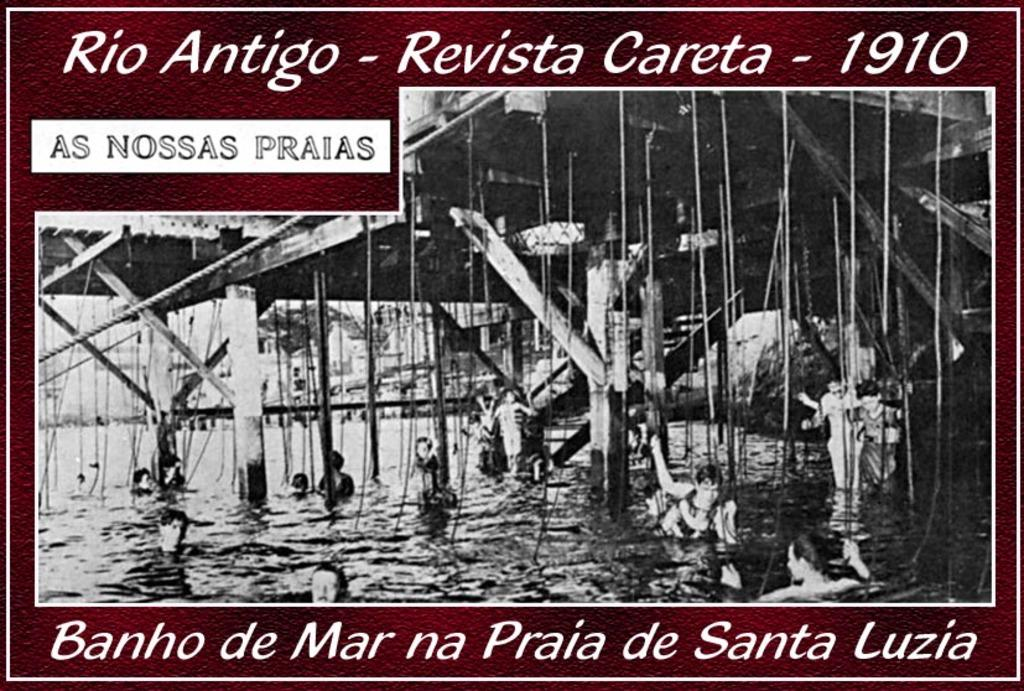What is present on the poster in the image? There is a poster in the image that contains images of persons and pillars. Is there any other element depicted in the poster? Yes, there is water depicted in the poster. How many jellyfish can be seen swimming in the water depicted in the poster? There are no jellyfish present in the image or the poster; it only contains images of persons, pillars, and water. 